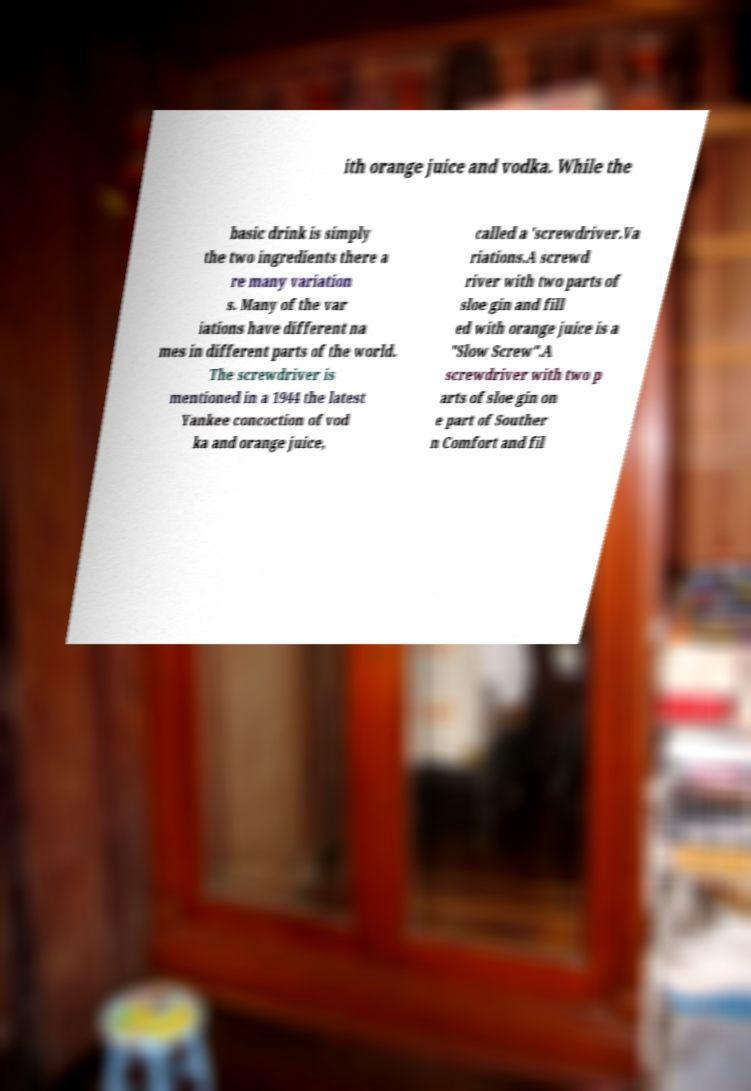Can you accurately transcribe the text from the provided image for me? ith orange juice and vodka. While the basic drink is simply the two ingredients there a re many variation s. Many of the var iations have different na mes in different parts of the world. The screwdriver is mentioned in a 1944 the latest Yankee concoction of vod ka and orange juice, called a 'screwdriver.Va riations.A screwd river with two parts of sloe gin and fill ed with orange juice is a "Slow Screw".A screwdriver with two p arts of sloe gin on e part of Souther n Comfort and fil 